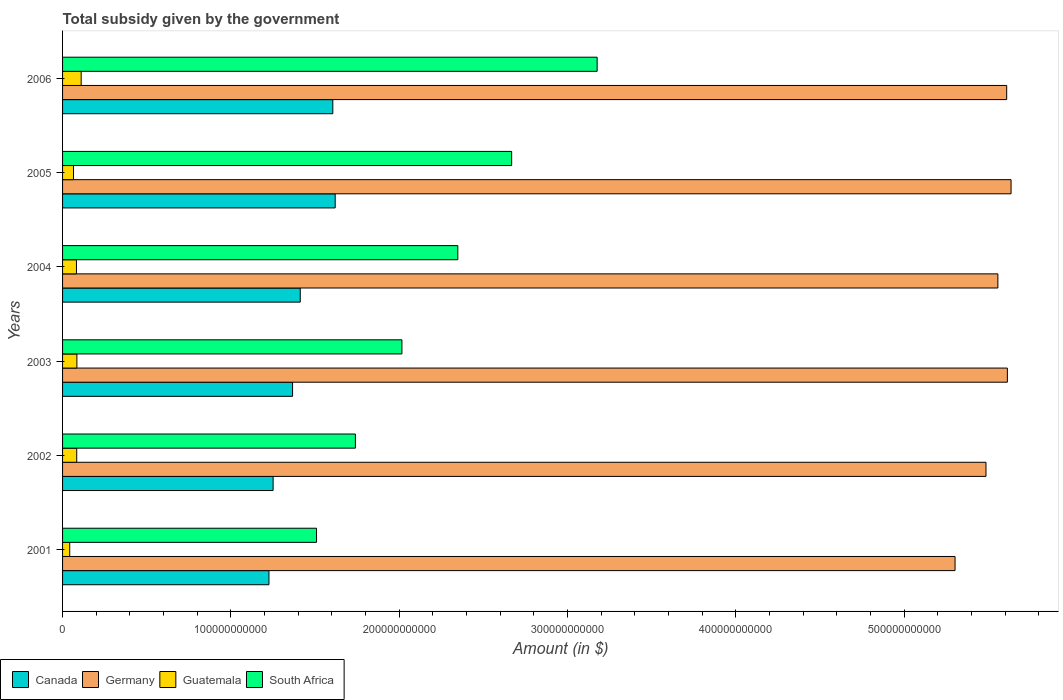How many different coloured bars are there?
Offer a very short reply. 4. How many bars are there on the 5th tick from the top?
Give a very brief answer. 4. How many bars are there on the 5th tick from the bottom?
Offer a very short reply. 4. What is the label of the 6th group of bars from the top?
Your answer should be very brief. 2001. In how many cases, is the number of bars for a given year not equal to the number of legend labels?
Keep it short and to the point. 0. What is the total revenue collected by the government in Germany in 2005?
Keep it short and to the point. 5.64e+11. Across all years, what is the maximum total revenue collected by the government in Canada?
Make the answer very short. 1.62e+11. Across all years, what is the minimum total revenue collected by the government in Canada?
Your answer should be compact. 1.23e+11. In which year was the total revenue collected by the government in Canada minimum?
Give a very brief answer. 2001. What is the total total revenue collected by the government in Canada in the graph?
Provide a short and direct response. 8.48e+11. What is the difference between the total revenue collected by the government in Canada in 2001 and that in 2004?
Offer a terse response. -1.86e+1. What is the difference between the total revenue collected by the government in Canada in 2005 and the total revenue collected by the government in Germany in 2001?
Offer a terse response. -3.68e+11. What is the average total revenue collected by the government in Guatemala per year?
Make the answer very short. 7.83e+09. In the year 2006, what is the difference between the total revenue collected by the government in South Africa and total revenue collected by the government in Germany?
Provide a succinct answer. -2.43e+11. In how many years, is the total revenue collected by the government in Guatemala greater than 100000000000 $?
Your answer should be very brief. 0. What is the ratio of the total revenue collected by the government in South Africa in 2001 to that in 2005?
Give a very brief answer. 0.57. What is the difference between the highest and the second highest total revenue collected by the government in Guatemala?
Offer a terse response. 2.55e+09. What is the difference between the highest and the lowest total revenue collected by the government in Guatemala?
Offer a terse response. 6.80e+09. What does the 4th bar from the bottom in 2006 represents?
Offer a terse response. South Africa. Is it the case that in every year, the sum of the total revenue collected by the government in Canada and total revenue collected by the government in South Africa is greater than the total revenue collected by the government in Guatemala?
Your answer should be compact. Yes. What is the difference between two consecutive major ticks on the X-axis?
Keep it short and to the point. 1.00e+11. Are the values on the major ticks of X-axis written in scientific E-notation?
Your answer should be compact. No. Does the graph contain any zero values?
Your response must be concise. No. How many legend labels are there?
Provide a short and direct response. 4. What is the title of the graph?
Offer a terse response. Total subsidy given by the government. What is the label or title of the X-axis?
Your answer should be compact. Amount (in $). What is the label or title of the Y-axis?
Provide a succinct answer. Years. What is the Amount (in $) in Canada in 2001?
Make the answer very short. 1.23e+11. What is the Amount (in $) in Germany in 2001?
Ensure brevity in your answer.  5.30e+11. What is the Amount (in $) in Guatemala in 2001?
Ensure brevity in your answer.  4.25e+09. What is the Amount (in $) of South Africa in 2001?
Your answer should be compact. 1.51e+11. What is the Amount (in $) in Canada in 2002?
Offer a very short reply. 1.25e+11. What is the Amount (in $) of Germany in 2002?
Your answer should be compact. 5.49e+11. What is the Amount (in $) in Guatemala in 2002?
Provide a short and direct response. 8.41e+09. What is the Amount (in $) in South Africa in 2002?
Your answer should be compact. 1.74e+11. What is the Amount (in $) in Canada in 2003?
Provide a short and direct response. 1.37e+11. What is the Amount (in $) in Germany in 2003?
Provide a succinct answer. 5.61e+11. What is the Amount (in $) in Guatemala in 2003?
Provide a succinct answer. 8.51e+09. What is the Amount (in $) of South Africa in 2003?
Ensure brevity in your answer.  2.02e+11. What is the Amount (in $) in Canada in 2004?
Your response must be concise. 1.41e+11. What is the Amount (in $) in Germany in 2004?
Keep it short and to the point. 5.56e+11. What is the Amount (in $) in Guatemala in 2004?
Your answer should be very brief. 8.25e+09. What is the Amount (in $) of South Africa in 2004?
Offer a terse response. 2.35e+11. What is the Amount (in $) of Canada in 2005?
Your answer should be compact. 1.62e+11. What is the Amount (in $) in Germany in 2005?
Provide a short and direct response. 5.64e+11. What is the Amount (in $) of Guatemala in 2005?
Keep it short and to the point. 6.49e+09. What is the Amount (in $) in South Africa in 2005?
Your answer should be very brief. 2.67e+11. What is the Amount (in $) of Canada in 2006?
Offer a very short reply. 1.61e+11. What is the Amount (in $) in Germany in 2006?
Keep it short and to the point. 5.61e+11. What is the Amount (in $) of Guatemala in 2006?
Provide a short and direct response. 1.11e+1. What is the Amount (in $) of South Africa in 2006?
Provide a short and direct response. 3.18e+11. Across all years, what is the maximum Amount (in $) of Canada?
Give a very brief answer. 1.62e+11. Across all years, what is the maximum Amount (in $) of Germany?
Offer a very short reply. 5.64e+11. Across all years, what is the maximum Amount (in $) of Guatemala?
Your response must be concise. 1.11e+1. Across all years, what is the maximum Amount (in $) of South Africa?
Give a very brief answer. 3.18e+11. Across all years, what is the minimum Amount (in $) of Canada?
Your response must be concise. 1.23e+11. Across all years, what is the minimum Amount (in $) of Germany?
Keep it short and to the point. 5.30e+11. Across all years, what is the minimum Amount (in $) in Guatemala?
Provide a succinct answer. 4.25e+09. Across all years, what is the minimum Amount (in $) of South Africa?
Make the answer very short. 1.51e+11. What is the total Amount (in $) in Canada in the graph?
Ensure brevity in your answer.  8.48e+11. What is the total Amount (in $) of Germany in the graph?
Keep it short and to the point. 3.32e+12. What is the total Amount (in $) of Guatemala in the graph?
Keep it short and to the point. 4.70e+1. What is the total Amount (in $) of South Africa in the graph?
Give a very brief answer. 1.35e+12. What is the difference between the Amount (in $) in Canada in 2001 and that in 2002?
Your answer should be very brief. -2.47e+09. What is the difference between the Amount (in $) of Germany in 2001 and that in 2002?
Offer a terse response. -1.84e+1. What is the difference between the Amount (in $) in Guatemala in 2001 and that in 2002?
Make the answer very short. -4.16e+09. What is the difference between the Amount (in $) of South Africa in 2001 and that in 2002?
Ensure brevity in your answer.  -2.31e+1. What is the difference between the Amount (in $) of Canada in 2001 and that in 2003?
Keep it short and to the point. -1.40e+1. What is the difference between the Amount (in $) of Germany in 2001 and that in 2003?
Your response must be concise. -3.11e+1. What is the difference between the Amount (in $) of Guatemala in 2001 and that in 2003?
Offer a very short reply. -4.26e+09. What is the difference between the Amount (in $) of South Africa in 2001 and that in 2003?
Your response must be concise. -5.07e+1. What is the difference between the Amount (in $) of Canada in 2001 and that in 2004?
Your response must be concise. -1.86e+1. What is the difference between the Amount (in $) in Germany in 2001 and that in 2004?
Provide a short and direct response. -2.54e+1. What is the difference between the Amount (in $) in Guatemala in 2001 and that in 2004?
Your answer should be compact. -3.99e+09. What is the difference between the Amount (in $) in South Africa in 2001 and that in 2004?
Your answer should be very brief. -8.40e+1. What is the difference between the Amount (in $) in Canada in 2001 and that in 2005?
Your response must be concise. -3.94e+1. What is the difference between the Amount (in $) of Germany in 2001 and that in 2005?
Your response must be concise. -3.33e+1. What is the difference between the Amount (in $) of Guatemala in 2001 and that in 2005?
Offer a terse response. -2.23e+09. What is the difference between the Amount (in $) in South Africa in 2001 and that in 2005?
Keep it short and to the point. -1.16e+11. What is the difference between the Amount (in $) in Canada in 2001 and that in 2006?
Give a very brief answer. -3.79e+1. What is the difference between the Amount (in $) of Germany in 2001 and that in 2006?
Your answer should be very brief. -3.07e+1. What is the difference between the Amount (in $) in Guatemala in 2001 and that in 2006?
Your response must be concise. -6.80e+09. What is the difference between the Amount (in $) of South Africa in 2001 and that in 2006?
Your answer should be compact. -1.67e+11. What is the difference between the Amount (in $) in Canada in 2002 and that in 2003?
Offer a terse response. -1.16e+1. What is the difference between the Amount (in $) of Germany in 2002 and that in 2003?
Provide a short and direct response. -1.27e+1. What is the difference between the Amount (in $) of Guatemala in 2002 and that in 2003?
Provide a succinct answer. -9.80e+07. What is the difference between the Amount (in $) in South Africa in 2002 and that in 2003?
Make the answer very short. -2.76e+1. What is the difference between the Amount (in $) of Canada in 2002 and that in 2004?
Make the answer very short. -1.61e+1. What is the difference between the Amount (in $) in Germany in 2002 and that in 2004?
Keep it short and to the point. -7.06e+09. What is the difference between the Amount (in $) in Guatemala in 2002 and that in 2004?
Offer a terse response. 1.66e+08. What is the difference between the Amount (in $) in South Africa in 2002 and that in 2004?
Make the answer very short. -6.09e+1. What is the difference between the Amount (in $) of Canada in 2002 and that in 2005?
Give a very brief answer. -3.69e+1. What is the difference between the Amount (in $) in Germany in 2002 and that in 2005?
Your answer should be compact. -1.49e+1. What is the difference between the Amount (in $) in Guatemala in 2002 and that in 2005?
Provide a succinct answer. 1.93e+09. What is the difference between the Amount (in $) in South Africa in 2002 and that in 2005?
Your answer should be compact. -9.28e+1. What is the difference between the Amount (in $) in Canada in 2002 and that in 2006?
Your response must be concise. -3.55e+1. What is the difference between the Amount (in $) of Germany in 2002 and that in 2006?
Give a very brief answer. -1.23e+1. What is the difference between the Amount (in $) of Guatemala in 2002 and that in 2006?
Provide a succinct answer. -2.64e+09. What is the difference between the Amount (in $) of South Africa in 2002 and that in 2006?
Your answer should be very brief. -1.44e+11. What is the difference between the Amount (in $) in Canada in 2003 and that in 2004?
Offer a terse response. -4.56e+09. What is the difference between the Amount (in $) of Germany in 2003 and that in 2004?
Offer a terse response. 5.65e+09. What is the difference between the Amount (in $) of Guatemala in 2003 and that in 2004?
Your answer should be very brief. 2.64e+08. What is the difference between the Amount (in $) of South Africa in 2003 and that in 2004?
Offer a terse response. -3.32e+1. What is the difference between the Amount (in $) in Canada in 2003 and that in 2005?
Provide a short and direct response. -2.53e+1. What is the difference between the Amount (in $) in Germany in 2003 and that in 2005?
Provide a short and direct response. -2.19e+09. What is the difference between the Amount (in $) of Guatemala in 2003 and that in 2005?
Your answer should be very brief. 2.02e+09. What is the difference between the Amount (in $) of South Africa in 2003 and that in 2005?
Your answer should be compact. -6.52e+1. What is the difference between the Amount (in $) of Canada in 2003 and that in 2006?
Your response must be concise. -2.39e+1. What is the difference between the Amount (in $) of Germany in 2003 and that in 2006?
Keep it short and to the point. 4.10e+08. What is the difference between the Amount (in $) in Guatemala in 2003 and that in 2006?
Offer a terse response. -2.55e+09. What is the difference between the Amount (in $) in South Africa in 2003 and that in 2006?
Your answer should be compact. -1.16e+11. What is the difference between the Amount (in $) in Canada in 2004 and that in 2005?
Offer a very short reply. -2.08e+1. What is the difference between the Amount (in $) of Germany in 2004 and that in 2005?
Make the answer very short. -7.84e+09. What is the difference between the Amount (in $) of Guatemala in 2004 and that in 2005?
Provide a short and direct response. 1.76e+09. What is the difference between the Amount (in $) in South Africa in 2004 and that in 2005?
Your answer should be compact. -3.20e+1. What is the difference between the Amount (in $) in Canada in 2004 and that in 2006?
Your response must be concise. -1.94e+1. What is the difference between the Amount (in $) in Germany in 2004 and that in 2006?
Your answer should be very brief. -5.24e+09. What is the difference between the Amount (in $) in Guatemala in 2004 and that in 2006?
Give a very brief answer. -2.81e+09. What is the difference between the Amount (in $) in South Africa in 2004 and that in 2006?
Provide a short and direct response. -8.28e+1. What is the difference between the Amount (in $) in Canada in 2005 and that in 2006?
Give a very brief answer. 1.41e+09. What is the difference between the Amount (in $) of Germany in 2005 and that in 2006?
Your answer should be compact. 2.60e+09. What is the difference between the Amount (in $) in Guatemala in 2005 and that in 2006?
Make the answer very short. -4.57e+09. What is the difference between the Amount (in $) of South Africa in 2005 and that in 2006?
Your answer should be very brief. -5.08e+1. What is the difference between the Amount (in $) of Canada in 2001 and the Amount (in $) of Germany in 2002?
Offer a very short reply. -4.26e+11. What is the difference between the Amount (in $) in Canada in 2001 and the Amount (in $) in Guatemala in 2002?
Make the answer very short. 1.14e+11. What is the difference between the Amount (in $) in Canada in 2001 and the Amount (in $) in South Africa in 2002?
Give a very brief answer. -5.14e+1. What is the difference between the Amount (in $) in Germany in 2001 and the Amount (in $) in Guatemala in 2002?
Provide a succinct answer. 5.22e+11. What is the difference between the Amount (in $) in Germany in 2001 and the Amount (in $) in South Africa in 2002?
Provide a short and direct response. 3.56e+11. What is the difference between the Amount (in $) of Guatemala in 2001 and the Amount (in $) of South Africa in 2002?
Offer a terse response. -1.70e+11. What is the difference between the Amount (in $) in Canada in 2001 and the Amount (in $) in Germany in 2003?
Make the answer very short. -4.39e+11. What is the difference between the Amount (in $) of Canada in 2001 and the Amount (in $) of Guatemala in 2003?
Your answer should be very brief. 1.14e+11. What is the difference between the Amount (in $) of Canada in 2001 and the Amount (in $) of South Africa in 2003?
Your answer should be very brief. -7.90e+1. What is the difference between the Amount (in $) of Germany in 2001 and the Amount (in $) of Guatemala in 2003?
Your answer should be very brief. 5.22e+11. What is the difference between the Amount (in $) of Germany in 2001 and the Amount (in $) of South Africa in 2003?
Your answer should be very brief. 3.29e+11. What is the difference between the Amount (in $) in Guatemala in 2001 and the Amount (in $) in South Africa in 2003?
Provide a succinct answer. -1.97e+11. What is the difference between the Amount (in $) in Canada in 2001 and the Amount (in $) in Germany in 2004?
Your answer should be very brief. -4.33e+11. What is the difference between the Amount (in $) in Canada in 2001 and the Amount (in $) in Guatemala in 2004?
Offer a very short reply. 1.14e+11. What is the difference between the Amount (in $) in Canada in 2001 and the Amount (in $) in South Africa in 2004?
Ensure brevity in your answer.  -1.12e+11. What is the difference between the Amount (in $) in Germany in 2001 and the Amount (in $) in Guatemala in 2004?
Give a very brief answer. 5.22e+11. What is the difference between the Amount (in $) in Germany in 2001 and the Amount (in $) in South Africa in 2004?
Make the answer very short. 2.95e+11. What is the difference between the Amount (in $) of Guatemala in 2001 and the Amount (in $) of South Africa in 2004?
Ensure brevity in your answer.  -2.31e+11. What is the difference between the Amount (in $) of Canada in 2001 and the Amount (in $) of Germany in 2005?
Offer a very short reply. -4.41e+11. What is the difference between the Amount (in $) of Canada in 2001 and the Amount (in $) of Guatemala in 2005?
Provide a succinct answer. 1.16e+11. What is the difference between the Amount (in $) in Canada in 2001 and the Amount (in $) in South Africa in 2005?
Your answer should be compact. -1.44e+11. What is the difference between the Amount (in $) of Germany in 2001 and the Amount (in $) of Guatemala in 2005?
Provide a short and direct response. 5.24e+11. What is the difference between the Amount (in $) in Germany in 2001 and the Amount (in $) in South Africa in 2005?
Give a very brief answer. 2.63e+11. What is the difference between the Amount (in $) in Guatemala in 2001 and the Amount (in $) in South Africa in 2005?
Offer a terse response. -2.63e+11. What is the difference between the Amount (in $) of Canada in 2001 and the Amount (in $) of Germany in 2006?
Keep it short and to the point. -4.38e+11. What is the difference between the Amount (in $) in Canada in 2001 and the Amount (in $) in Guatemala in 2006?
Make the answer very short. 1.12e+11. What is the difference between the Amount (in $) of Canada in 2001 and the Amount (in $) of South Africa in 2006?
Give a very brief answer. -1.95e+11. What is the difference between the Amount (in $) of Germany in 2001 and the Amount (in $) of Guatemala in 2006?
Your response must be concise. 5.19e+11. What is the difference between the Amount (in $) in Germany in 2001 and the Amount (in $) in South Africa in 2006?
Keep it short and to the point. 2.13e+11. What is the difference between the Amount (in $) of Guatemala in 2001 and the Amount (in $) of South Africa in 2006?
Your answer should be very brief. -3.13e+11. What is the difference between the Amount (in $) in Canada in 2002 and the Amount (in $) in Germany in 2003?
Keep it short and to the point. -4.36e+11. What is the difference between the Amount (in $) of Canada in 2002 and the Amount (in $) of Guatemala in 2003?
Your answer should be very brief. 1.17e+11. What is the difference between the Amount (in $) in Canada in 2002 and the Amount (in $) in South Africa in 2003?
Your answer should be very brief. -7.65e+1. What is the difference between the Amount (in $) in Germany in 2002 and the Amount (in $) in Guatemala in 2003?
Your answer should be compact. 5.40e+11. What is the difference between the Amount (in $) of Germany in 2002 and the Amount (in $) of South Africa in 2003?
Ensure brevity in your answer.  3.47e+11. What is the difference between the Amount (in $) of Guatemala in 2002 and the Amount (in $) of South Africa in 2003?
Provide a succinct answer. -1.93e+11. What is the difference between the Amount (in $) in Canada in 2002 and the Amount (in $) in Germany in 2004?
Your response must be concise. -4.31e+11. What is the difference between the Amount (in $) of Canada in 2002 and the Amount (in $) of Guatemala in 2004?
Provide a succinct answer. 1.17e+11. What is the difference between the Amount (in $) in Canada in 2002 and the Amount (in $) in South Africa in 2004?
Ensure brevity in your answer.  -1.10e+11. What is the difference between the Amount (in $) in Germany in 2002 and the Amount (in $) in Guatemala in 2004?
Give a very brief answer. 5.40e+11. What is the difference between the Amount (in $) in Germany in 2002 and the Amount (in $) in South Africa in 2004?
Provide a succinct answer. 3.14e+11. What is the difference between the Amount (in $) in Guatemala in 2002 and the Amount (in $) in South Africa in 2004?
Ensure brevity in your answer.  -2.26e+11. What is the difference between the Amount (in $) of Canada in 2002 and the Amount (in $) of Germany in 2005?
Offer a very short reply. -4.38e+11. What is the difference between the Amount (in $) in Canada in 2002 and the Amount (in $) in Guatemala in 2005?
Make the answer very short. 1.19e+11. What is the difference between the Amount (in $) of Canada in 2002 and the Amount (in $) of South Africa in 2005?
Offer a very short reply. -1.42e+11. What is the difference between the Amount (in $) of Germany in 2002 and the Amount (in $) of Guatemala in 2005?
Make the answer very short. 5.42e+11. What is the difference between the Amount (in $) in Germany in 2002 and the Amount (in $) in South Africa in 2005?
Provide a short and direct response. 2.82e+11. What is the difference between the Amount (in $) in Guatemala in 2002 and the Amount (in $) in South Africa in 2005?
Provide a short and direct response. -2.58e+11. What is the difference between the Amount (in $) in Canada in 2002 and the Amount (in $) in Germany in 2006?
Give a very brief answer. -4.36e+11. What is the difference between the Amount (in $) in Canada in 2002 and the Amount (in $) in Guatemala in 2006?
Make the answer very short. 1.14e+11. What is the difference between the Amount (in $) of Canada in 2002 and the Amount (in $) of South Africa in 2006?
Your answer should be compact. -1.93e+11. What is the difference between the Amount (in $) of Germany in 2002 and the Amount (in $) of Guatemala in 2006?
Offer a terse response. 5.38e+11. What is the difference between the Amount (in $) in Germany in 2002 and the Amount (in $) in South Africa in 2006?
Your answer should be very brief. 2.31e+11. What is the difference between the Amount (in $) in Guatemala in 2002 and the Amount (in $) in South Africa in 2006?
Ensure brevity in your answer.  -3.09e+11. What is the difference between the Amount (in $) of Canada in 2003 and the Amount (in $) of Germany in 2004?
Give a very brief answer. -4.19e+11. What is the difference between the Amount (in $) of Canada in 2003 and the Amount (in $) of Guatemala in 2004?
Offer a very short reply. 1.28e+11. What is the difference between the Amount (in $) of Canada in 2003 and the Amount (in $) of South Africa in 2004?
Your response must be concise. -9.82e+1. What is the difference between the Amount (in $) in Germany in 2003 and the Amount (in $) in Guatemala in 2004?
Your answer should be compact. 5.53e+11. What is the difference between the Amount (in $) in Germany in 2003 and the Amount (in $) in South Africa in 2004?
Offer a terse response. 3.27e+11. What is the difference between the Amount (in $) of Guatemala in 2003 and the Amount (in $) of South Africa in 2004?
Your answer should be very brief. -2.26e+11. What is the difference between the Amount (in $) of Canada in 2003 and the Amount (in $) of Germany in 2005?
Provide a succinct answer. -4.27e+11. What is the difference between the Amount (in $) in Canada in 2003 and the Amount (in $) in Guatemala in 2005?
Make the answer very short. 1.30e+11. What is the difference between the Amount (in $) in Canada in 2003 and the Amount (in $) in South Africa in 2005?
Ensure brevity in your answer.  -1.30e+11. What is the difference between the Amount (in $) of Germany in 2003 and the Amount (in $) of Guatemala in 2005?
Ensure brevity in your answer.  5.55e+11. What is the difference between the Amount (in $) in Germany in 2003 and the Amount (in $) in South Africa in 2005?
Provide a succinct answer. 2.95e+11. What is the difference between the Amount (in $) in Guatemala in 2003 and the Amount (in $) in South Africa in 2005?
Ensure brevity in your answer.  -2.58e+11. What is the difference between the Amount (in $) of Canada in 2003 and the Amount (in $) of Germany in 2006?
Ensure brevity in your answer.  -4.24e+11. What is the difference between the Amount (in $) of Canada in 2003 and the Amount (in $) of Guatemala in 2006?
Provide a succinct answer. 1.26e+11. What is the difference between the Amount (in $) in Canada in 2003 and the Amount (in $) in South Africa in 2006?
Give a very brief answer. -1.81e+11. What is the difference between the Amount (in $) of Germany in 2003 and the Amount (in $) of Guatemala in 2006?
Your answer should be very brief. 5.50e+11. What is the difference between the Amount (in $) in Germany in 2003 and the Amount (in $) in South Africa in 2006?
Provide a short and direct response. 2.44e+11. What is the difference between the Amount (in $) in Guatemala in 2003 and the Amount (in $) in South Africa in 2006?
Provide a short and direct response. -3.09e+11. What is the difference between the Amount (in $) of Canada in 2004 and the Amount (in $) of Germany in 2005?
Keep it short and to the point. -4.22e+11. What is the difference between the Amount (in $) in Canada in 2004 and the Amount (in $) in Guatemala in 2005?
Your response must be concise. 1.35e+11. What is the difference between the Amount (in $) of Canada in 2004 and the Amount (in $) of South Africa in 2005?
Offer a terse response. -1.26e+11. What is the difference between the Amount (in $) in Germany in 2004 and the Amount (in $) in Guatemala in 2005?
Offer a terse response. 5.49e+11. What is the difference between the Amount (in $) of Germany in 2004 and the Amount (in $) of South Africa in 2005?
Offer a terse response. 2.89e+11. What is the difference between the Amount (in $) of Guatemala in 2004 and the Amount (in $) of South Africa in 2005?
Provide a short and direct response. -2.59e+11. What is the difference between the Amount (in $) in Canada in 2004 and the Amount (in $) in Germany in 2006?
Make the answer very short. -4.20e+11. What is the difference between the Amount (in $) of Canada in 2004 and the Amount (in $) of Guatemala in 2006?
Make the answer very short. 1.30e+11. What is the difference between the Amount (in $) in Canada in 2004 and the Amount (in $) in South Africa in 2006?
Ensure brevity in your answer.  -1.76e+11. What is the difference between the Amount (in $) in Germany in 2004 and the Amount (in $) in Guatemala in 2006?
Provide a succinct answer. 5.45e+11. What is the difference between the Amount (in $) of Germany in 2004 and the Amount (in $) of South Africa in 2006?
Give a very brief answer. 2.38e+11. What is the difference between the Amount (in $) in Guatemala in 2004 and the Amount (in $) in South Africa in 2006?
Your answer should be very brief. -3.09e+11. What is the difference between the Amount (in $) of Canada in 2005 and the Amount (in $) of Germany in 2006?
Ensure brevity in your answer.  -3.99e+11. What is the difference between the Amount (in $) in Canada in 2005 and the Amount (in $) in Guatemala in 2006?
Provide a short and direct response. 1.51e+11. What is the difference between the Amount (in $) of Canada in 2005 and the Amount (in $) of South Africa in 2006?
Keep it short and to the point. -1.56e+11. What is the difference between the Amount (in $) of Germany in 2005 and the Amount (in $) of Guatemala in 2006?
Provide a short and direct response. 5.53e+11. What is the difference between the Amount (in $) of Germany in 2005 and the Amount (in $) of South Africa in 2006?
Keep it short and to the point. 2.46e+11. What is the difference between the Amount (in $) in Guatemala in 2005 and the Amount (in $) in South Africa in 2006?
Ensure brevity in your answer.  -3.11e+11. What is the average Amount (in $) of Canada per year?
Make the answer very short. 1.41e+11. What is the average Amount (in $) of Germany per year?
Make the answer very short. 5.53e+11. What is the average Amount (in $) of Guatemala per year?
Offer a terse response. 7.83e+09. What is the average Amount (in $) of South Africa per year?
Provide a short and direct response. 2.24e+11. In the year 2001, what is the difference between the Amount (in $) in Canada and Amount (in $) in Germany?
Offer a terse response. -4.08e+11. In the year 2001, what is the difference between the Amount (in $) of Canada and Amount (in $) of Guatemala?
Provide a short and direct response. 1.18e+11. In the year 2001, what is the difference between the Amount (in $) in Canada and Amount (in $) in South Africa?
Keep it short and to the point. -2.83e+1. In the year 2001, what is the difference between the Amount (in $) of Germany and Amount (in $) of Guatemala?
Give a very brief answer. 5.26e+11. In the year 2001, what is the difference between the Amount (in $) of Germany and Amount (in $) of South Africa?
Provide a succinct answer. 3.79e+11. In the year 2001, what is the difference between the Amount (in $) of Guatemala and Amount (in $) of South Africa?
Ensure brevity in your answer.  -1.47e+11. In the year 2002, what is the difference between the Amount (in $) in Canada and Amount (in $) in Germany?
Keep it short and to the point. -4.24e+11. In the year 2002, what is the difference between the Amount (in $) of Canada and Amount (in $) of Guatemala?
Provide a short and direct response. 1.17e+11. In the year 2002, what is the difference between the Amount (in $) of Canada and Amount (in $) of South Africa?
Your answer should be compact. -4.89e+1. In the year 2002, what is the difference between the Amount (in $) in Germany and Amount (in $) in Guatemala?
Keep it short and to the point. 5.40e+11. In the year 2002, what is the difference between the Amount (in $) in Germany and Amount (in $) in South Africa?
Your response must be concise. 3.75e+11. In the year 2002, what is the difference between the Amount (in $) of Guatemala and Amount (in $) of South Africa?
Your response must be concise. -1.66e+11. In the year 2003, what is the difference between the Amount (in $) in Canada and Amount (in $) in Germany?
Make the answer very short. -4.25e+11. In the year 2003, what is the difference between the Amount (in $) of Canada and Amount (in $) of Guatemala?
Provide a succinct answer. 1.28e+11. In the year 2003, what is the difference between the Amount (in $) of Canada and Amount (in $) of South Africa?
Your response must be concise. -6.50e+1. In the year 2003, what is the difference between the Amount (in $) of Germany and Amount (in $) of Guatemala?
Keep it short and to the point. 5.53e+11. In the year 2003, what is the difference between the Amount (in $) of Germany and Amount (in $) of South Africa?
Give a very brief answer. 3.60e+11. In the year 2003, what is the difference between the Amount (in $) of Guatemala and Amount (in $) of South Africa?
Your answer should be very brief. -1.93e+11. In the year 2004, what is the difference between the Amount (in $) of Canada and Amount (in $) of Germany?
Your answer should be very brief. -4.15e+11. In the year 2004, what is the difference between the Amount (in $) of Canada and Amount (in $) of Guatemala?
Make the answer very short. 1.33e+11. In the year 2004, what is the difference between the Amount (in $) in Canada and Amount (in $) in South Africa?
Provide a short and direct response. -9.36e+1. In the year 2004, what is the difference between the Amount (in $) of Germany and Amount (in $) of Guatemala?
Ensure brevity in your answer.  5.47e+11. In the year 2004, what is the difference between the Amount (in $) in Germany and Amount (in $) in South Africa?
Make the answer very short. 3.21e+11. In the year 2004, what is the difference between the Amount (in $) in Guatemala and Amount (in $) in South Africa?
Give a very brief answer. -2.27e+11. In the year 2005, what is the difference between the Amount (in $) in Canada and Amount (in $) in Germany?
Offer a terse response. -4.02e+11. In the year 2005, what is the difference between the Amount (in $) of Canada and Amount (in $) of Guatemala?
Provide a succinct answer. 1.55e+11. In the year 2005, what is the difference between the Amount (in $) in Canada and Amount (in $) in South Africa?
Your answer should be very brief. -1.05e+11. In the year 2005, what is the difference between the Amount (in $) in Germany and Amount (in $) in Guatemala?
Ensure brevity in your answer.  5.57e+11. In the year 2005, what is the difference between the Amount (in $) of Germany and Amount (in $) of South Africa?
Ensure brevity in your answer.  2.97e+11. In the year 2005, what is the difference between the Amount (in $) in Guatemala and Amount (in $) in South Africa?
Provide a succinct answer. -2.60e+11. In the year 2006, what is the difference between the Amount (in $) in Canada and Amount (in $) in Germany?
Offer a very short reply. -4.00e+11. In the year 2006, what is the difference between the Amount (in $) in Canada and Amount (in $) in Guatemala?
Offer a very short reply. 1.50e+11. In the year 2006, what is the difference between the Amount (in $) in Canada and Amount (in $) in South Africa?
Provide a succinct answer. -1.57e+11. In the year 2006, what is the difference between the Amount (in $) of Germany and Amount (in $) of Guatemala?
Provide a short and direct response. 5.50e+11. In the year 2006, what is the difference between the Amount (in $) in Germany and Amount (in $) in South Africa?
Offer a very short reply. 2.43e+11. In the year 2006, what is the difference between the Amount (in $) in Guatemala and Amount (in $) in South Africa?
Keep it short and to the point. -3.07e+11. What is the ratio of the Amount (in $) in Canada in 2001 to that in 2002?
Provide a succinct answer. 0.98. What is the ratio of the Amount (in $) in Germany in 2001 to that in 2002?
Ensure brevity in your answer.  0.97. What is the ratio of the Amount (in $) of Guatemala in 2001 to that in 2002?
Provide a short and direct response. 0.51. What is the ratio of the Amount (in $) of South Africa in 2001 to that in 2002?
Make the answer very short. 0.87. What is the ratio of the Amount (in $) of Canada in 2001 to that in 2003?
Give a very brief answer. 0.9. What is the ratio of the Amount (in $) in Germany in 2001 to that in 2003?
Offer a terse response. 0.94. What is the ratio of the Amount (in $) of Guatemala in 2001 to that in 2003?
Provide a short and direct response. 0.5. What is the ratio of the Amount (in $) of South Africa in 2001 to that in 2003?
Your answer should be compact. 0.75. What is the ratio of the Amount (in $) of Canada in 2001 to that in 2004?
Keep it short and to the point. 0.87. What is the ratio of the Amount (in $) in Germany in 2001 to that in 2004?
Keep it short and to the point. 0.95. What is the ratio of the Amount (in $) in Guatemala in 2001 to that in 2004?
Provide a short and direct response. 0.52. What is the ratio of the Amount (in $) in South Africa in 2001 to that in 2004?
Offer a terse response. 0.64. What is the ratio of the Amount (in $) in Canada in 2001 to that in 2005?
Provide a short and direct response. 0.76. What is the ratio of the Amount (in $) in Germany in 2001 to that in 2005?
Ensure brevity in your answer.  0.94. What is the ratio of the Amount (in $) of Guatemala in 2001 to that in 2005?
Keep it short and to the point. 0.66. What is the ratio of the Amount (in $) of South Africa in 2001 to that in 2005?
Ensure brevity in your answer.  0.57. What is the ratio of the Amount (in $) of Canada in 2001 to that in 2006?
Offer a very short reply. 0.76. What is the ratio of the Amount (in $) of Germany in 2001 to that in 2006?
Offer a terse response. 0.95. What is the ratio of the Amount (in $) of Guatemala in 2001 to that in 2006?
Offer a very short reply. 0.38. What is the ratio of the Amount (in $) in South Africa in 2001 to that in 2006?
Make the answer very short. 0.48. What is the ratio of the Amount (in $) in Canada in 2002 to that in 2003?
Offer a terse response. 0.92. What is the ratio of the Amount (in $) in Germany in 2002 to that in 2003?
Provide a succinct answer. 0.98. What is the ratio of the Amount (in $) in Guatemala in 2002 to that in 2003?
Your answer should be compact. 0.99. What is the ratio of the Amount (in $) of South Africa in 2002 to that in 2003?
Provide a short and direct response. 0.86. What is the ratio of the Amount (in $) of Canada in 2002 to that in 2004?
Make the answer very short. 0.89. What is the ratio of the Amount (in $) in Germany in 2002 to that in 2004?
Ensure brevity in your answer.  0.99. What is the ratio of the Amount (in $) in Guatemala in 2002 to that in 2004?
Offer a very short reply. 1.02. What is the ratio of the Amount (in $) of South Africa in 2002 to that in 2004?
Keep it short and to the point. 0.74. What is the ratio of the Amount (in $) in Canada in 2002 to that in 2005?
Your answer should be very brief. 0.77. What is the ratio of the Amount (in $) of Germany in 2002 to that in 2005?
Make the answer very short. 0.97. What is the ratio of the Amount (in $) of Guatemala in 2002 to that in 2005?
Offer a very short reply. 1.3. What is the ratio of the Amount (in $) in South Africa in 2002 to that in 2005?
Your response must be concise. 0.65. What is the ratio of the Amount (in $) of Canada in 2002 to that in 2006?
Your answer should be very brief. 0.78. What is the ratio of the Amount (in $) of Germany in 2002 to that in 2006?
Offer a terse response. 0.98. What is the ratio of the Amount (in $) in Guatemala in 2002 to that in 2006?
Ensure brevity in your answer.  0.76. What is the ratio of the Amount (in $) in South Africa in 2002 to that in 2006?
Ensure brevity in your answer.  0.55. What is the ratio of the Amount (in $) of Canada in 2003 to that in 2004?
Offer a terse response. 0.97. What is the ratio of the Amount (in $) in Germany in 2003 to that in 2004?
Your response must be concise. 1.01. What is the ratio of the Amount (in $) in Guatemala in 2003 to that in 2004?
Make the answer very short. 1.03. What is the ratio of the Amount (in $) in South Africa in 2003 to that in 2004?
Offer a very short reply. 0.86. What is the ratio of the Amount (in $) in Canada in 2003 to that in 2005?
Your response must be concise. 0.84. What is the ratio of the Amount (in $) in Guatemala in 2003 to that in 2005?
Offer a terse response. 1.31. What is the ratio of the Amount (in $) in South Africa in 2003 to that in 2005?
Give a very brief answer. 0.76. What is the ratio of the Amount (in $) in Canada in 2003 to that in 2006?
Provide a succinct answer. 0.85. What is the ratio of the Amount (in $) in Germany in 2003 to that in 2006?
Provide a short and direct response. 1. What is the ratio of the Amount (in $) in Guatemala in 2003 to that in 2006?
Provide a succinct answer. 0.77. What is the ratio of the Amount (in $) in South Africa in 2003 to that in 2006?
Your response must be concise. 0.63. What is the ratio of the Amount (in $) of Canada in 2004 to that in 2005?
Provide a short and direct response. 0.87. What is the ratio of the Amount (in $) of Germany in 2004 to that in 2005?
Provide a short and direct response. 0.99. What is the ratio of the Amount (in $) of Guatemala in 2004 to that in 2005?
Give a very brief answer. 1.27. What is the ratio of the Amount (in $) in South Africa in 2004 to that in 2005?
Give a very brief answer. 0.88. What is the ratio of the Amount (in $) of Canada in 2004 to that in 2006?
Give a very brief answer. 0.88. What is the ratio of the Amount (in $) in Germany in 2004 to that in 2006?
Keep it short and to the point. 0.99. What is the ratio of the Amount (in $) of Guatemala in 2004 to that in 2006?
Provide a succinct answer. 0.75. What is the ratio of the Amount (in $) in South Africa in 2004 to that in 2006?
Offer a very short reply. 0.74. What is the ratio of the Amount (in $) of Canada in 2005 to that in 2006?
Your response must be concise. 1.01. What is the ratio of the Amount (in $) in Guatemala in 2005 to that in 2006?
Keep it short and to the point. 0.59. What is the ratio of the Amount (in $) in South Africa in 2005 to that in 2006?
Make the answer very short. 0.84. What is the difference between the highest and the second highest Amount (in $) of Canada?
Keep it short and to the point. 1.41e+09. What is the difference between the highest and the second highest Amount (in $) in Germany?
Provide a succinct answer. 2.19e+09. What is the difference between the highest and the second highest Amount (in $) of Guatemala?
Give a very brief answer. 2.55e+09. What is the difference between the highest and the second highest Amount (in $) in South Africa?
Provide a succinct answer. 5.08e+1. What is the difference between the highest and the lowest Amount (in $) of Canada?
Ensure brevity in your answer.  3.94e+1. What is the difference between the highest and the lowest Amount (in $) in Germany?
Offer a very short reply. 3.33e+1. What is the difference between the highest and the lowest Amount (in $) in Guatemala?
Your answer should be compact. 6.80e+09. What is the difference between the highest and the lowest Amount (in $) in South Africa?
Give a very brief answer. 1.67e+11. 